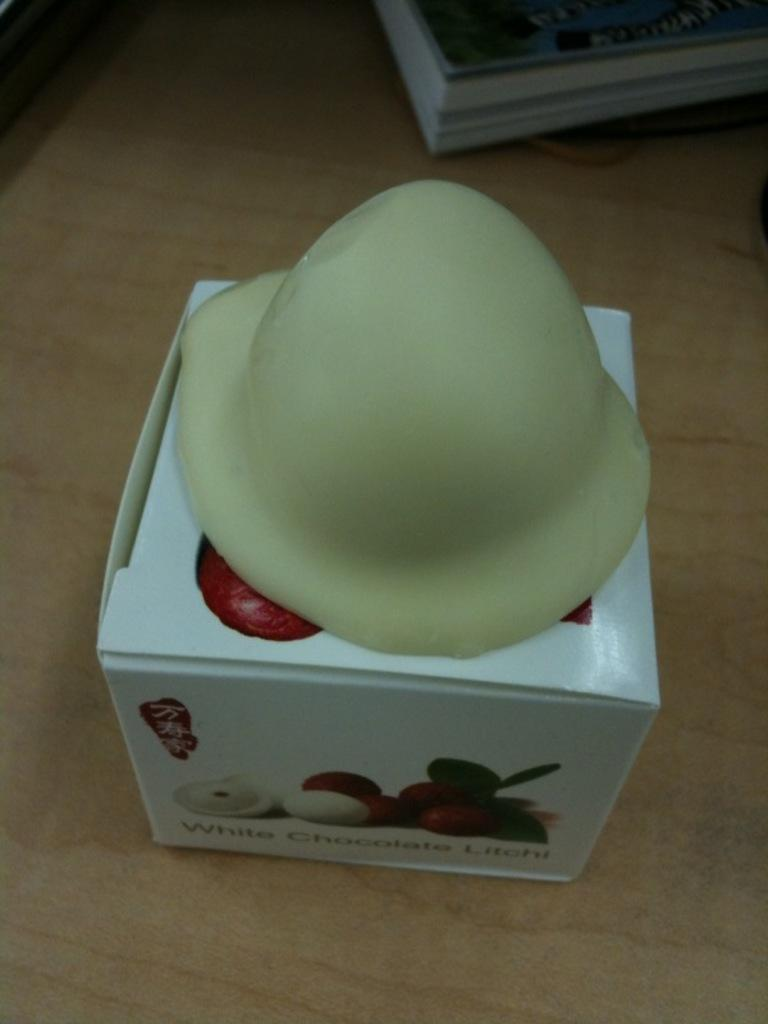What is the color of the box in the image? The box in the image is white. Where is the box located in the image? The box is placed on the floor. What is on top of the box in the image? There is a white color chocolate on the box. What other object can be seen in the image? There is a book visible at the top of the image. What type of apparel is being worn by the chocolate in the image? There is no apparel present in the image, as the chocolate is not a living being and does not wear clothing. 